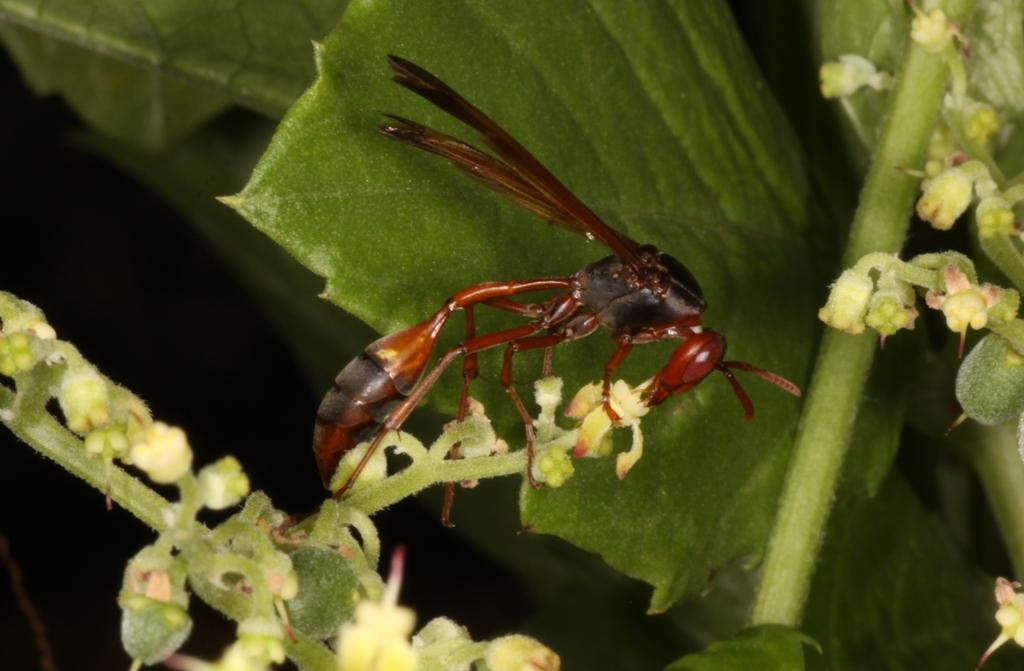What is present in the image? There is an insect in the image. What is the insect standing on? The insect is standing on a plant. What type of sound can be heard coming from the square in the image? There is no square present in the image, and therefore no sound can be heard coming from it. 